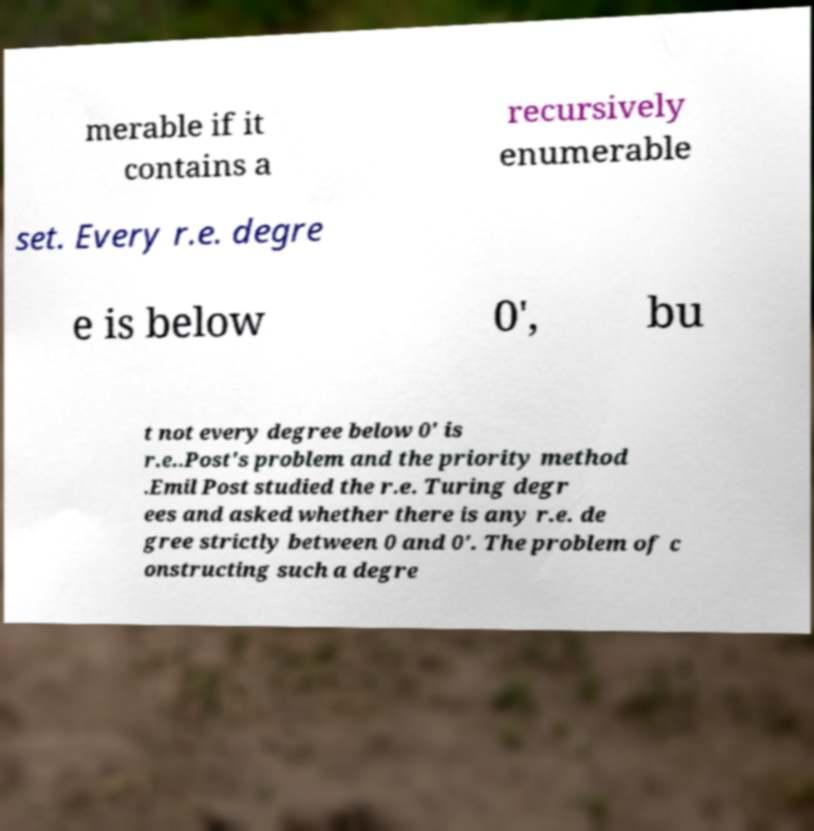For documentation purposes, I need the text within this image transcribed. Could you provide that? merable if it contains a recursively enumerable set. Every r.e. degre e is below 0′, bu t not every degree below 0′ is r.e..Post's problem and the priority method .Emil Post studied the r.e. Turing degr ees and asked whether there is any r.e. de gree strictly between 0 and 0′. The problem of c onstructing such a degre 